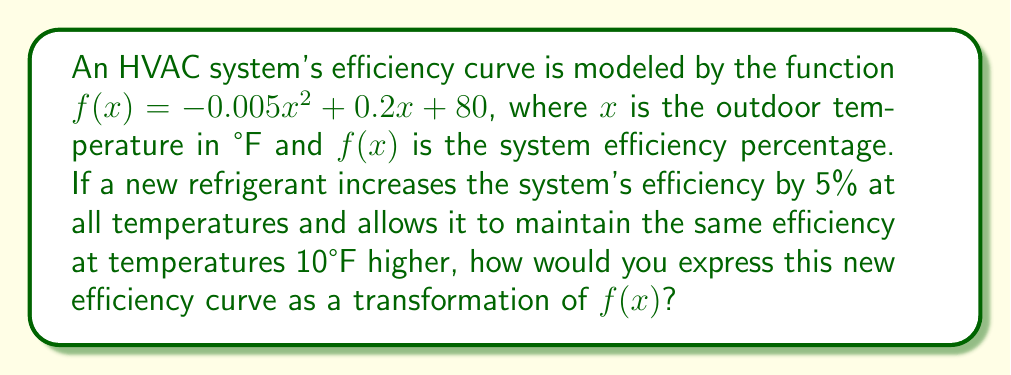Solve this math problem. To solve this problem, we need to apply two transformations to the original function $f(x)$:

1. Vertical stretch and shift:
   The efficiency increase of 5% at all temperatures can be represented by multiplying $f(x)$ by 1.05 (a 5% increase).
   $$g(x) = 1.05f(x)$$

2. Horizontal shift:
   The system maintaining the same efficiency at temperatures 10°F higher means we need to shift the function 10 units to the left.
   $$h(x) = g(x+10)$$

Combining these transformations:
$$h(x) = 1.05f(x+10)$$

To express this in terms of the original function:
$$h(x) = 1.05[-0.005(x+10)^2 + 0.2(x+10) + 80]$$

This can be simplified, but the question asks for the transformation of $f(x)$, so we leave it in this form.
Answer: $h(x) = 1.05f(x+10)$ 